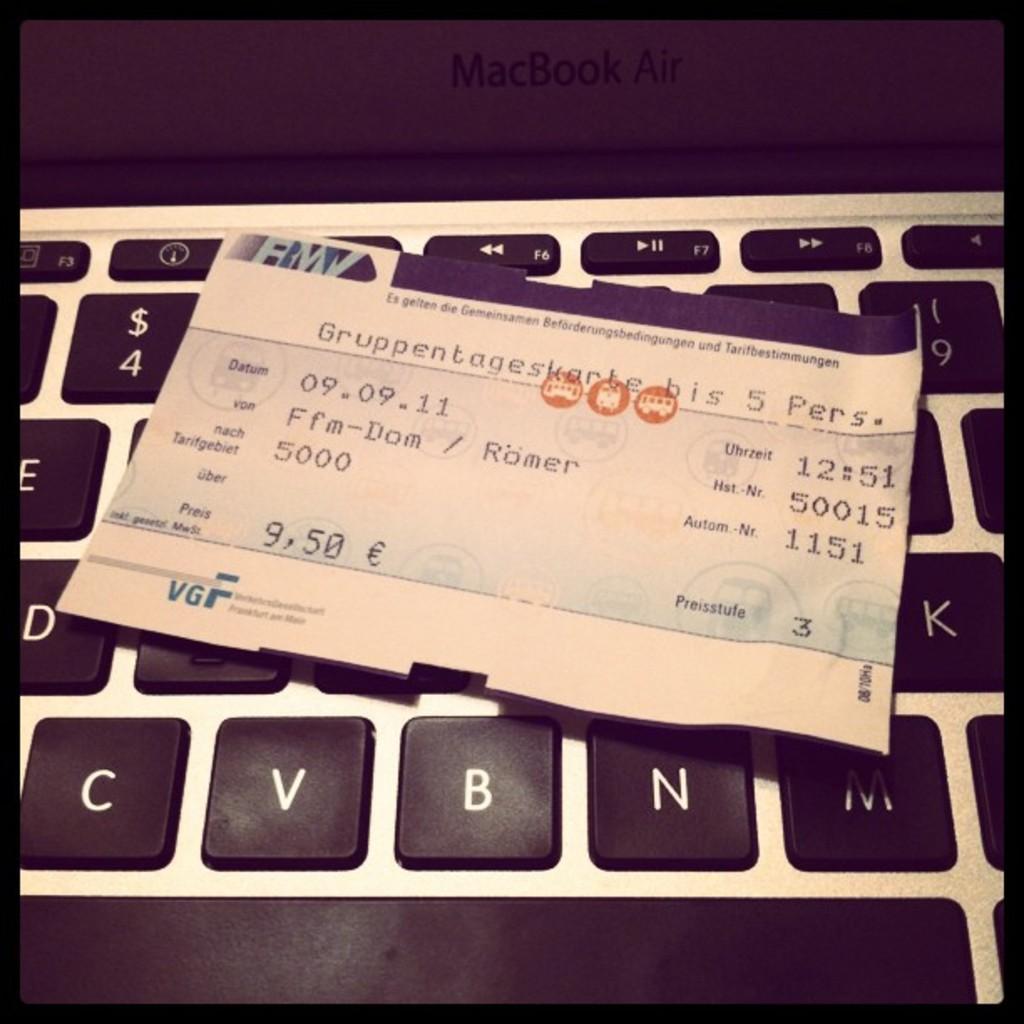How much is this ticket?
Provide a succinct answer. 9.50. What is the time printed?
Make the answer very short. 12:51. 